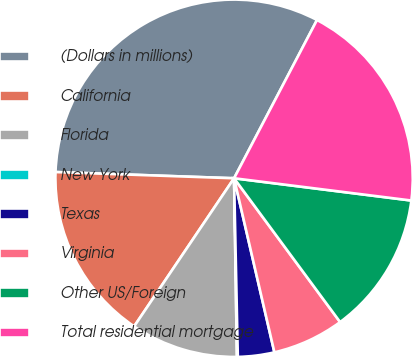Convert chart to OTSL. <chart><loc_0><loc_0><loc_500><loc_500><pie_chart><fcel>(Dollars in millions)<fcel>California<fcel>Florida<fcel>New York<fcel>Texas<fcel>Virginia<fcel>Other US/Foreign<fcel>Total residential mortgage<nl><fcel>32.13%<fcel>16.11%<fcel>9.7%<fcel>0.08%<fcel>3.29%<fcel>6.49%<fcel>12.9%<fcel>19.31%<nl></chart> 